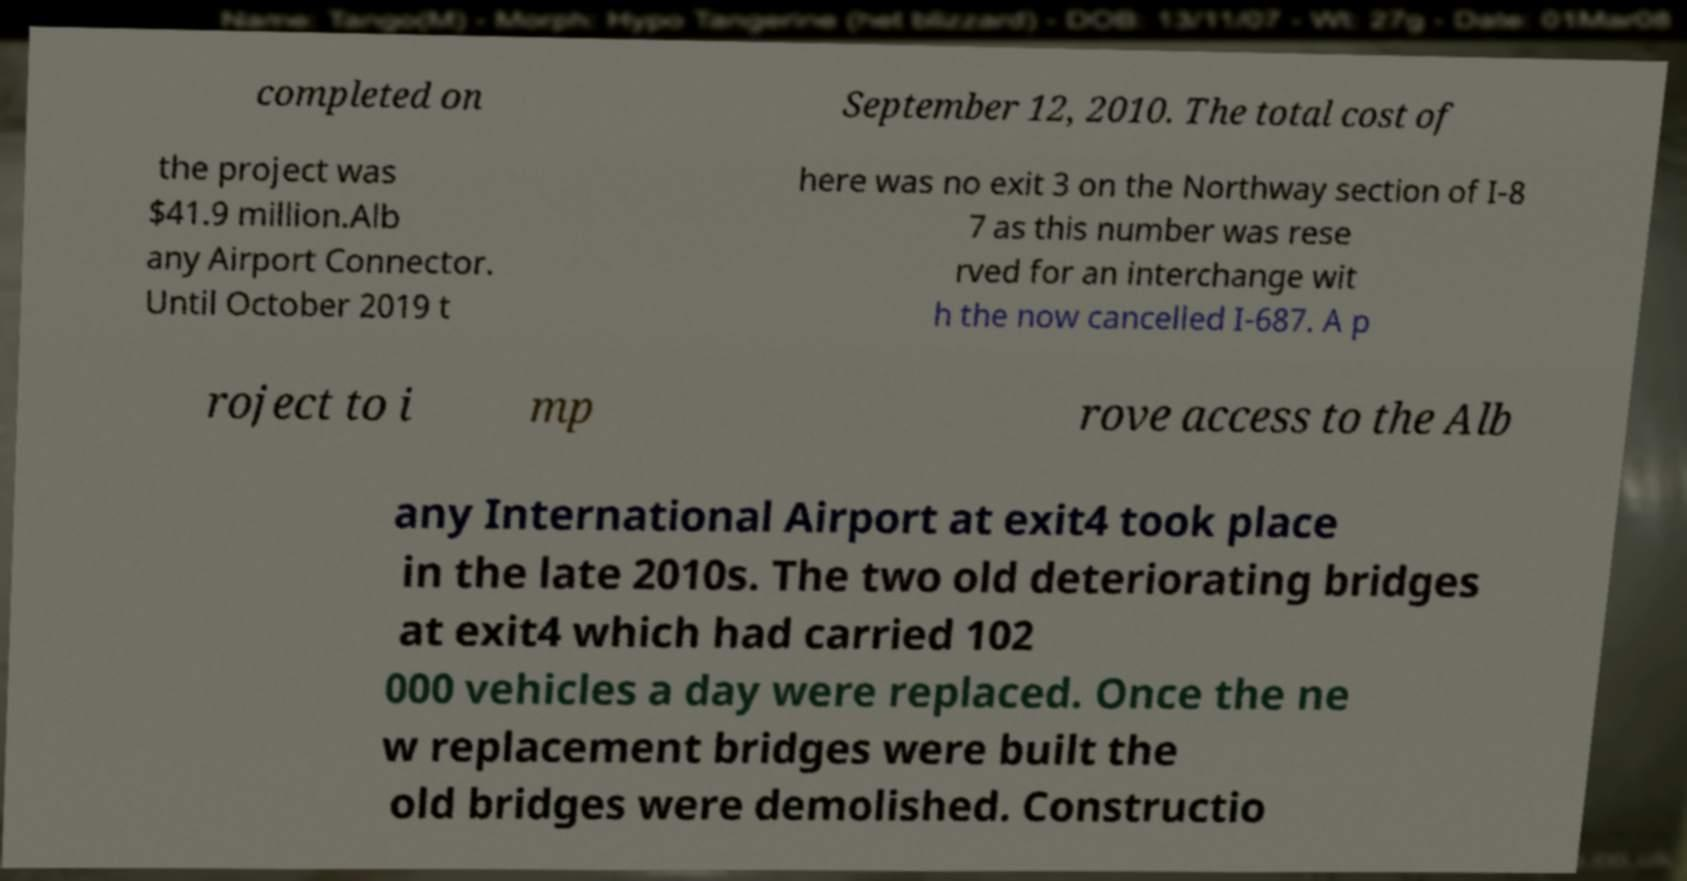Can you read and provide the text displayed in the image?This photo seems to have some interesting text. Can you extract and type it out for me? completed on September 12, 2010. The total cost of the project was $41.9 million.Alb any Airport Connector. Until October 2019 t here was no exit 3 on the Northway section of I-8 7 as this number was rese rved for an interchange wit h the now cancelled I-687. A p roject to i mp rove access to the Alb any International Airport at exit4 took place in the late 2010s. The two old deteriorating bridges at exit4 which had carried 102 000 vehicles a day were replaced. Once the ne w replacement bridges were built the old bridges were demolished. Constructio 